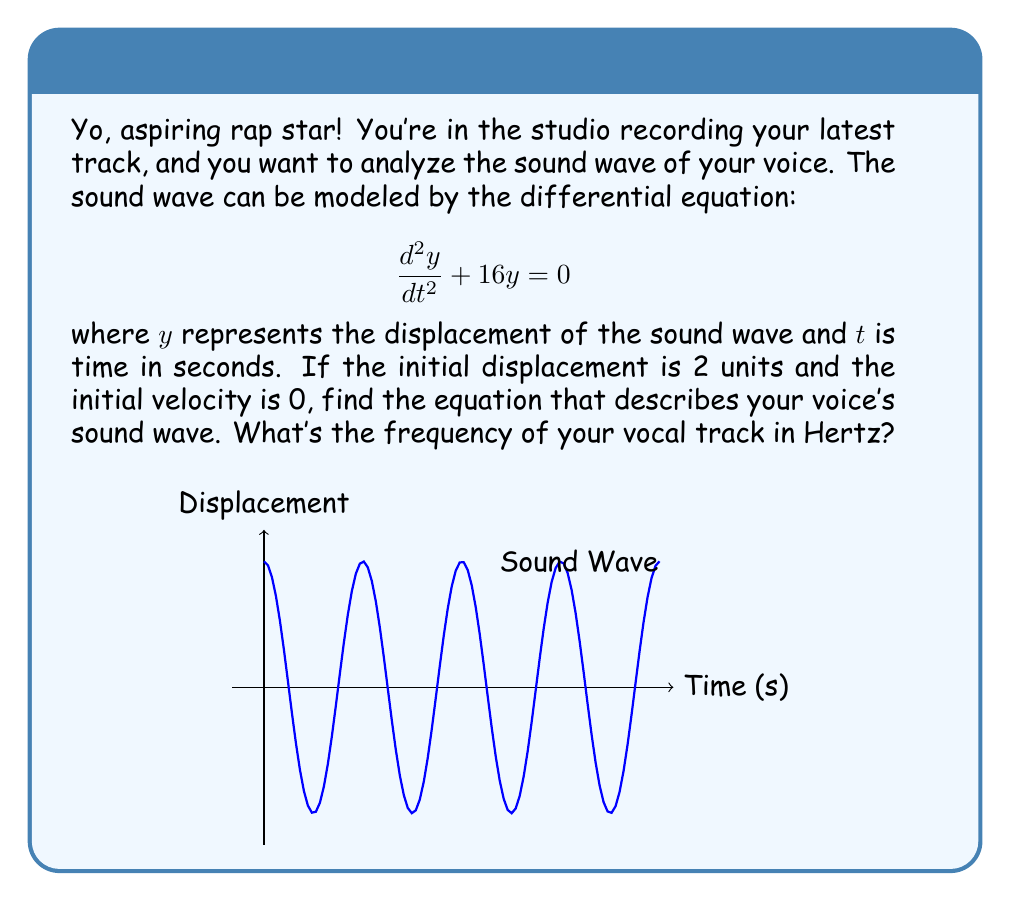Can you solve this math problem? Alright, let's break this down step by step:

1) The given differential equation is in the form of a simple harmonic oscillator:
   $$\frac{d^2y}{dt^2} + \omega^2y = 0$$
   where $\omega^2 = 16$, so $\omega = 4$ rad/s.

2) The general solution for this equation is:
   $$y(t) = A\cos(\omega t) + B\sin(\omega t)$$

3) Substituting $\omega = 4$:
   $$y(t) = A\cos(4t) + B\sin(4t)$$

4) Now, we use the initial conditions:
   At $t = 0$, $y(0) = 2$ (initial displacement)
   At $t = 0$, $\frac{dy}{dt}(0) = 0$ (initial velocity)

5) Applying the first condition:
   $y(0) = A\cos(0) + B\sin(0) = A = 2$

6) For the second condition, we differentiate $y(t)$:
   $$\frac{dy}{dt} = -4A\sin(4t) + 4B\cos(4t)$$
   At $t = 0$: $0 = 0 + 4B$, so $B = 0$

7) Therefore, the equation of the sound wave is:
   $$y(t) = 2\cos(4t)$$

8) To find the frequency in Hertz, we use the relation $f = \frac{\omega}{2\pi}$:
   $$f = \frac{4}{2\pi} = \frac{2}{\pi} \approx 0.64 \text{ Hz}$$
Answer: $y(t) = 2\cos(4t)$; $f \approx 0.64 \text{ Hz}$ 